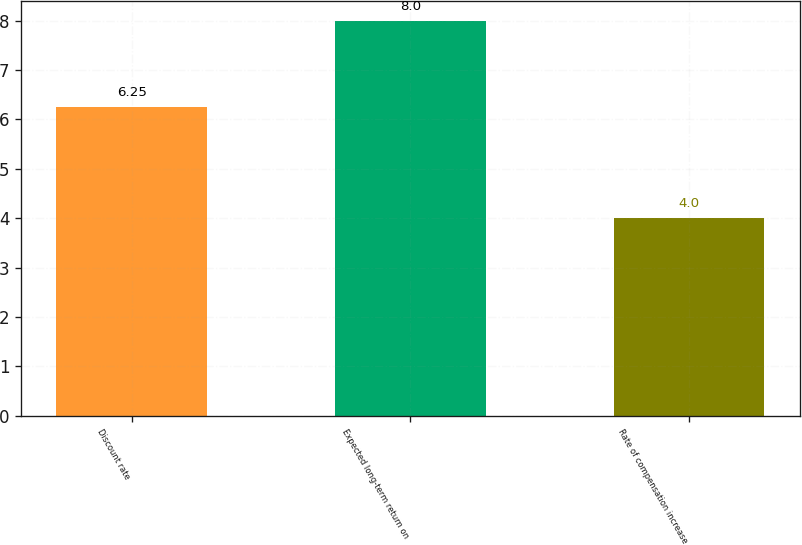<chart> <loc_0><loc_0><loc_500><loc_500><bar_chart><fcel>Discount rate<fcel>Expected long-term return on<fcel>Rate of compensation increase<nl><fcel>6.25<fcel>8<fcel>4<nl></chart> 